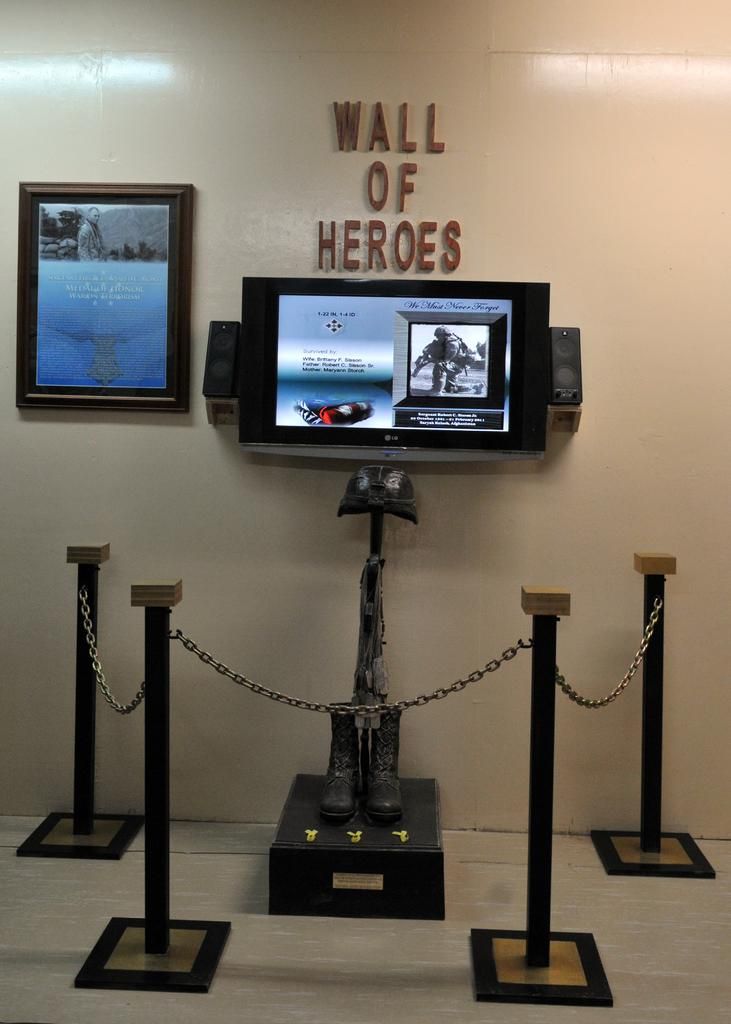What type of structure can be seen in the image? There is a fence in the image. What other objects can be seen in the image? There are poles, shoes, a TV, speakers, a photo frame, and text visible in the image. What type of surface is present in the image? There is a wall in the image. Can you describe the setting where the image might have been taken? The image may have been taken in a hall. How does the baby express anger in the image? There is no baby present in the image, so it is not possible to determine how a baby might express anger. 